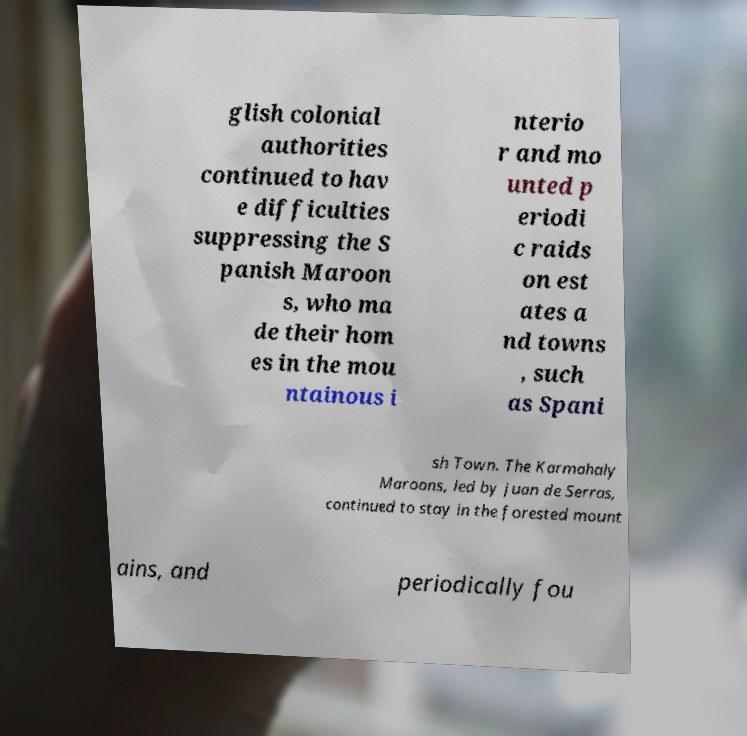Could you extract and type out the text from this image? glish colonial authorities continued to hav e difficulties suppressing the S panish Maroon s, who ma de their hom es in the mou ntainous i nterio r and mo unted p eriodi c raids on est ates a nd towns , such as Spani sh Town. The Karmahaly Maroons, led by Juan de Serras, continued to stay in the forested mount ains, and periodically fou 